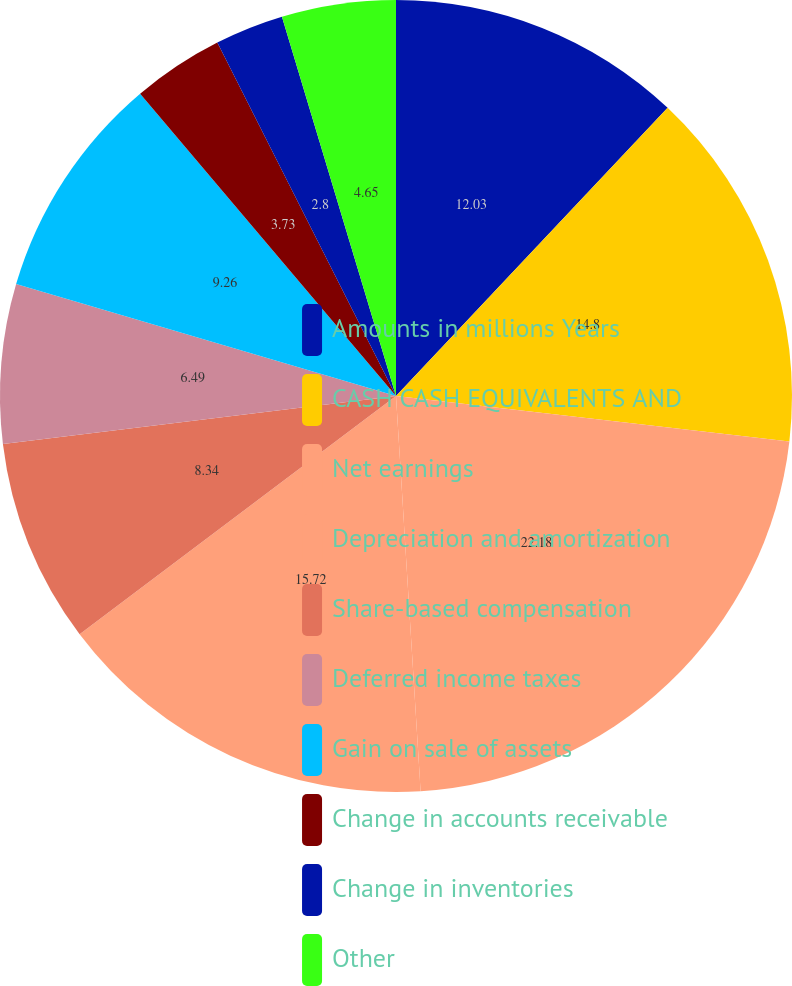<chart> <loc_0><loc_0><loc_500><loc_500><pie_chart><fcel>Amounts in millions Years<fcel>CASH CASH EQUIVALENTS AND<fcel>Net earnings<fcel>Depreciation and amortization<fcel>Share-based compensation<fcel>Deferred income taxes<fcel>Gain on sale of assets<fcel>Change in accounts receivable<fcel>Change in inventories<fcel>Other<nl><fcel>12.03%<fcel>14.8%<fcel>22.18%<fcel>15.72%<fcel>8.34%<fcel>6.49%<fcel>9.26%<fcel>3.73%<fcel>2.8%<fcel>4.65%<nl></chart> 